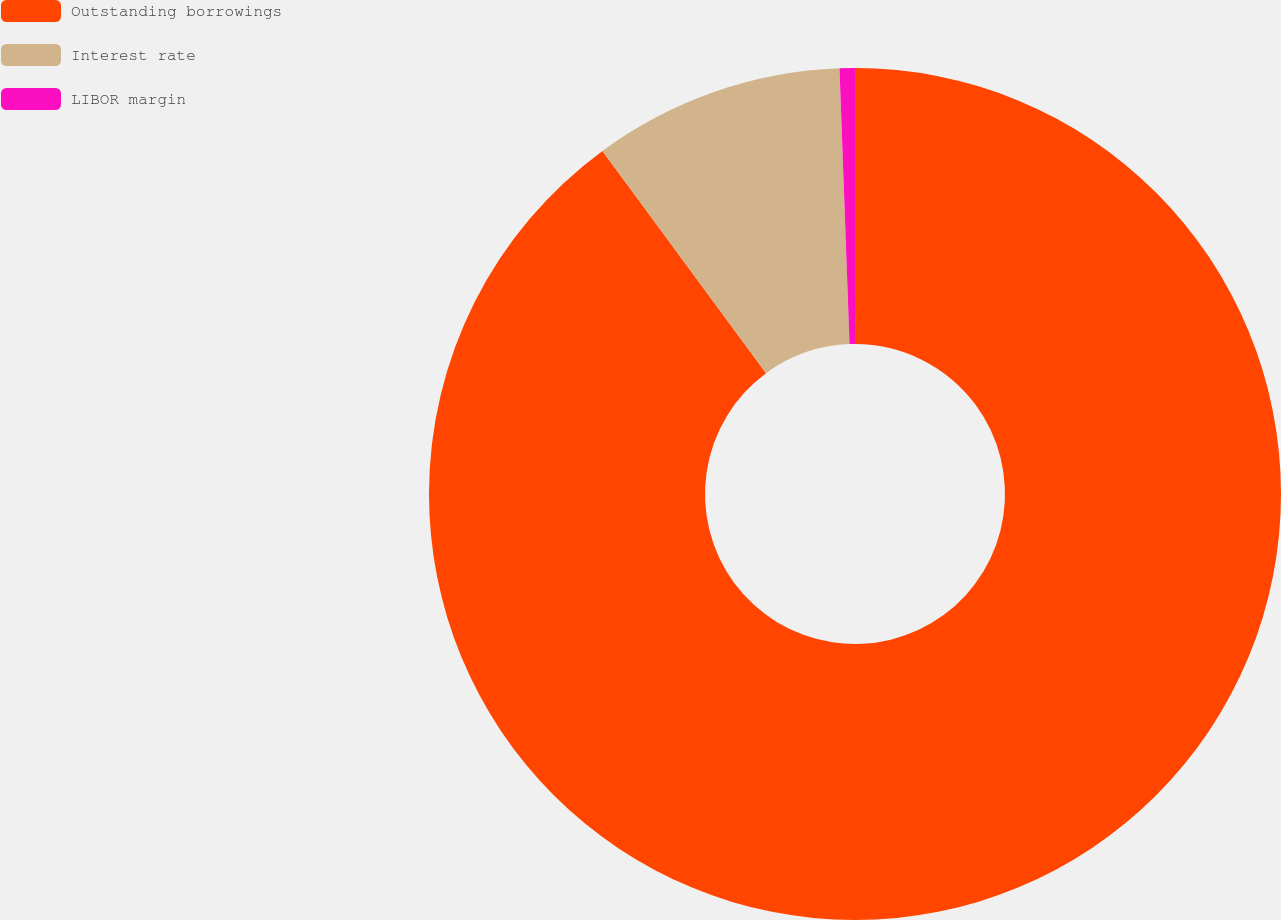Convert chart. <chart><loc_0><loc_0><loc_500><loc_500><pie_chart><fcel>Outstanding borrowings<fcel>Interest rate<fcel>LIBOR margin<nl><fcel>89.9%<fcel>9.52%<fcel>0.58%<nl></chart> 